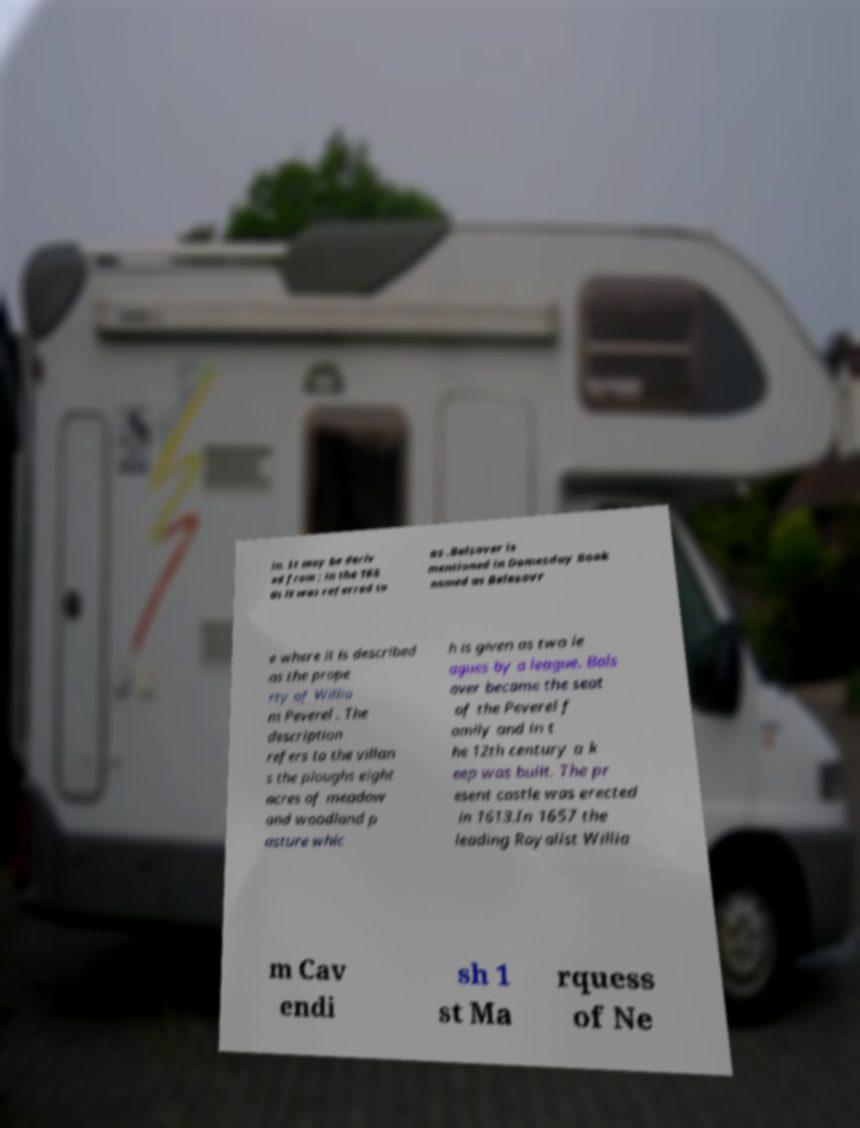Can you accurately transcribe the text from the provided image for me? in. It may be deriv ed from ; in the 165 0s it was referred to as .Bolsover is mentioned in Domesday Book named as Belesovr e where it is described as the prope rty of Willia m Peverel . The description refers to the villan s the ploughs eight acres of meadow and woodland p asture whic h is given as two le agues by a league. Bols over became the seat of the Peverel f amily and in t he 12th century a k eep was built. The pr esent castle was erected in 1613.In 1657 the leading Royalist Willia m Cav endi sh 1 st Ma rquess of Ne 